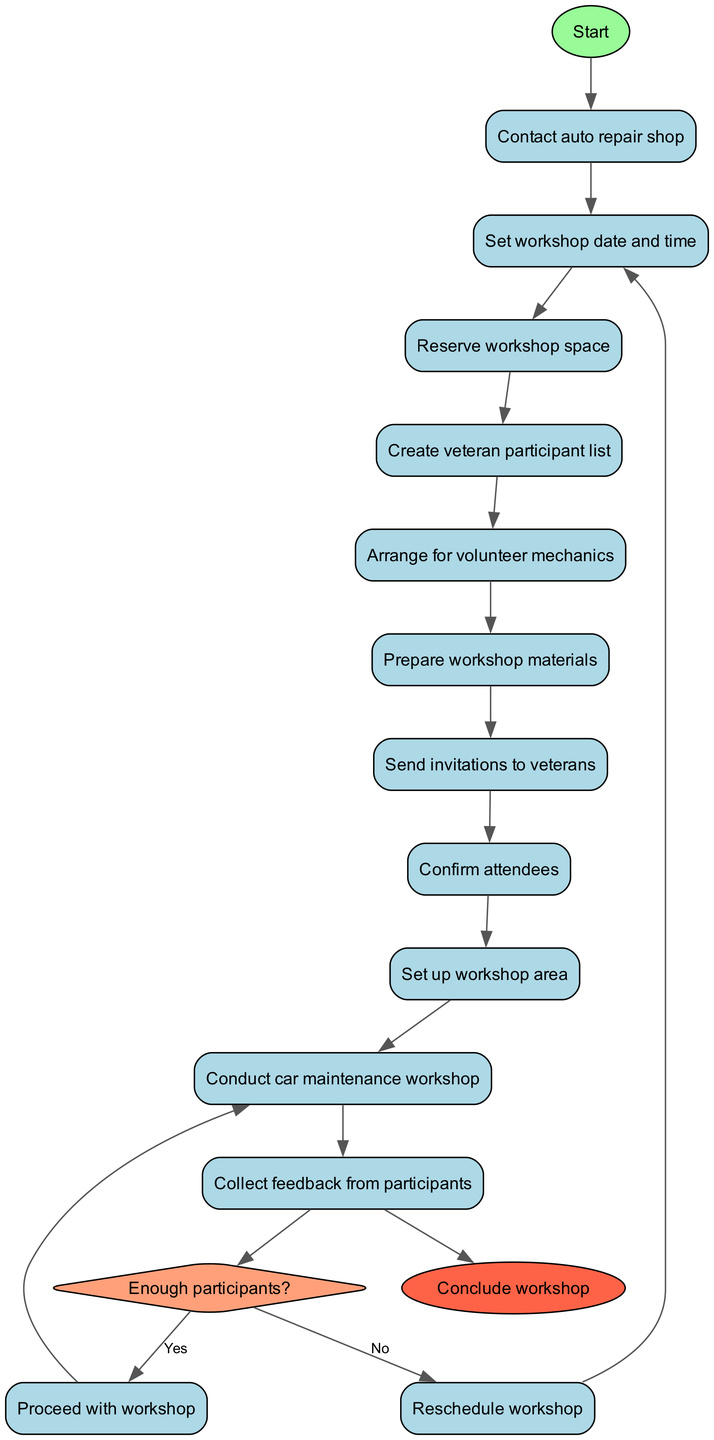What is the first activity in the diagram? The first activity listed in the diagram is "Contact auto repair shop," which is the first node connected after the start node.
Answer: Contact auto repair shop How many activities are there in total? The diagram lists a total of 11 activities, including the "Conduct car maintenance workshop." These are counted from the list provided in the data.
Answer: 11 What happens if there are not enough participants? If there are not enough participants, the flow indicates that the workshop is rescheduled, as shown by the edge leading from the "no" node back to "Set workshop date and time."
Answer: Reschedule workshop Which activity follows "Send invitations to veterans"? The activity that follows "Send invitations to veterans" is "Confirm attendees," which is directly connected in the sequence of activities listed.
Answer: Confirm attendees What is the endpoint of the diagram? The endpoint of the diagram is labeled as "Conclude workshop," which is the final node connected after the last activity.
Answer: Conclude workshop How many decision points are present in this diagram? There is one decision point in the diagram regarding whether there are enough participants, which is represented by a diamond-shaped node.
Answer: 1 What is the last activity before the end node? The last activity before the end node is "Collect feedback from participants," which connects directly to the endpoint.
Answer: Collect feedback from participants What do you do after confirming attendees? After confirming attendees, the next step is to check if there are enough participants, leading to the decision point in the flow.
Answer: Check enough participants Explain the direction of flow from "Conduct car maintenance workshop." After "Conduct car maintenance workshop," the flow moves directly to "Collect feedback from participants," indicating a sequential progression to gather participant responses.
Answer: Collect feedback from participants 